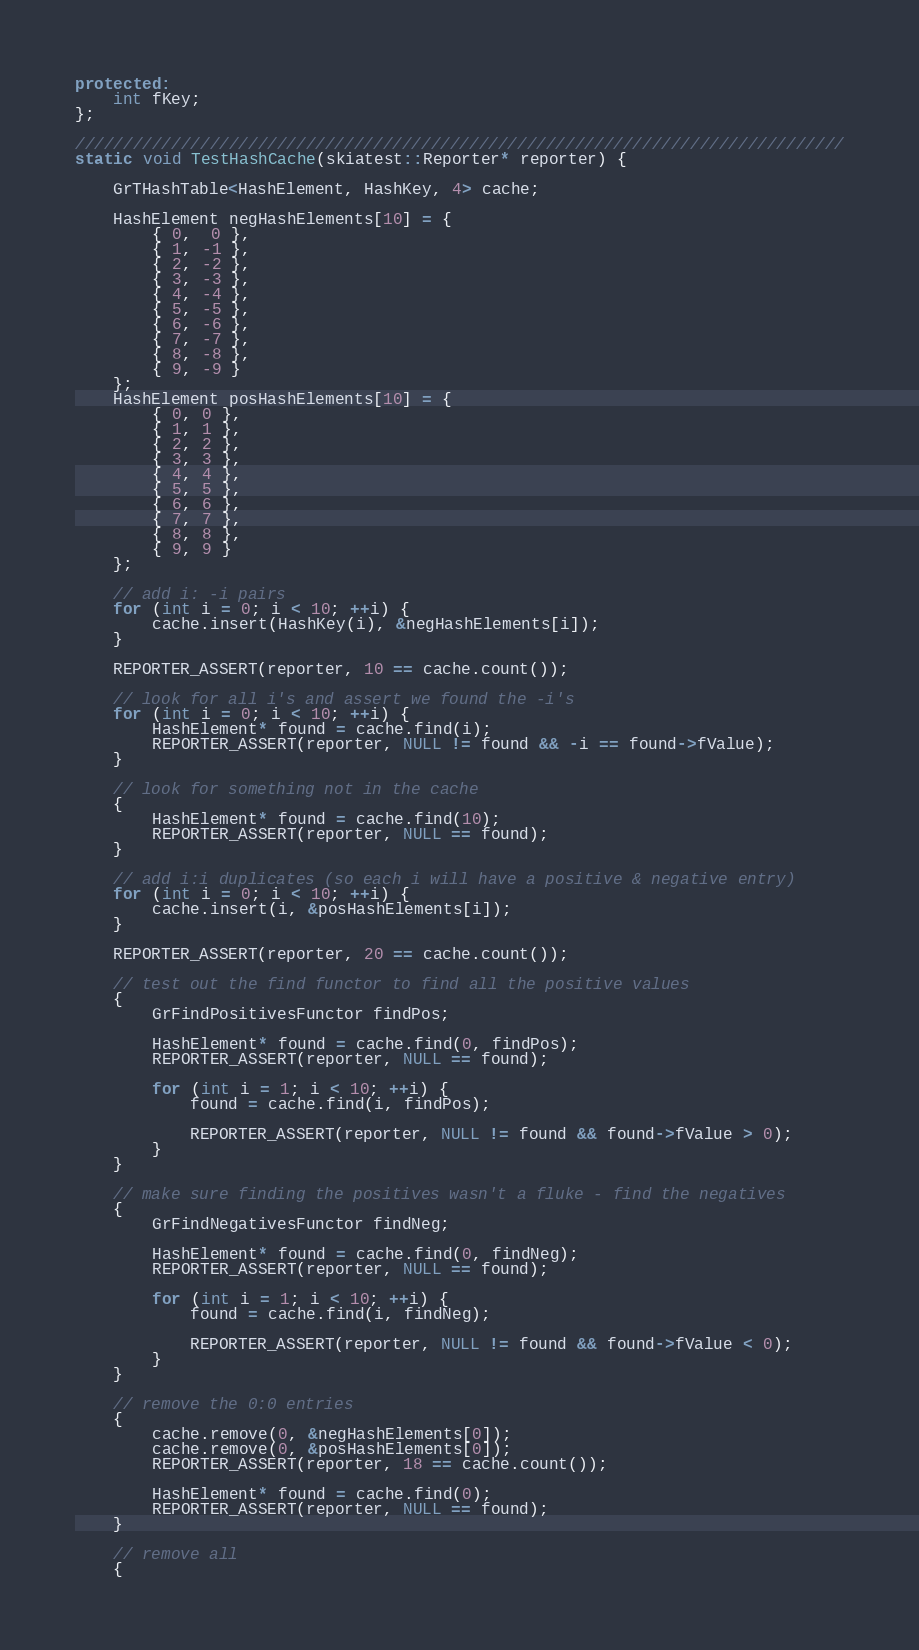Convert code to text. <code><loc_0><loc_0><loc_500><loc_500><_C++_>protected:
    int fKey;
};

////////////////////////////////////////////////////////////////////////////////
static void TestHashCache(skiatest::Reporter* reporter) {

    GrTHashTable<HashElement, HashKey, 4> cache;

    HashElement negHashElements[10] = {
        { 0,  0 },
        { 1, -1 },
        { 2, -2 },
        { 3, -3 },
        { 4, -4 },
        { 5, -5 },
        { 6, -6 },
        { 7, -7 },
        { 8, -8 },
        { 9, -9 }
    };
    HashElement posHashElements[10] = {
        { 0, 0 },
        { 1, 1 },
        { 2, 2 },
        { 3, 3 },
        { 4, 4 },
        { 5, 5 },
        { 6, 6 },
        { 7, 7 },
        { 8, 8 },
        { 9, 9 }
    };

    // add i: -i pairs
    for (int i = 0; i < 10; ++i) {
        cache.insert(HashKey(i), &negHashElements[i]);
    }

    REPORTER_ASSERT(reporter, 10 == cache.count());

    // look for all i's and assert we found the -i's
    for (int i = 0; i < 10; ++i) {
        HashElement* found = cache.find(i);
        REPORTER_ASSERT(reporter, NULL != found && -i == found->fValue);
    }

    // look for something not in the cache
    {
        HashElement* found = cache.find(10);
        REPORTER_ASSERT(reporter, NULL == found);
    }

    // add i:i duplicates (so each i will have a positive & negative entry)
    for (int i = 0; i < 10; ++i) {
        cache.insert(i, &posHashElements[i]);
    }

    REPORTER_ASSERT(reporter, 20 == cache.count());

    // test out the find functor to find all the positive values
    {
        GrFindPositivesFunctor findPos;

        HashElement* found = cache.find(0, findPos);
        REPORTER_ASSERT(reporter, NULL == found);

        for (int i = 1; i < 10; ++i) {
            found = cache.find(i, findPos);

            REPORTER_ASSERT(reporter, NULL != found && found->fValue > 0);
        }
    }

    // make sure finding the positives wasn't a fluke - find the negatives
    {
        GrFindNegativesFunctor findNeg;

        HashElement* found = cache.find(0, findNeg);
        REPORTER_ASSERT(reporter, NULL == found);

        for (int i = 1; i < 10; ++i) {
            found = cache.find(i, findNeg);

            REPORTER_ASSERT(reporter, NULL != found && found->fValue < 0);
        }
    }

    // remove the 0:0 entries
    {
        cache.remove(0, &negHashElements[0]);
        cache.remove(0, &posHashElements[0]);
        REPORTER_ASSERT(reporter, 18 == cache.count());

        HashElement* found = cache.find(0);
        REPORTER_ASSERT(reporter, NULL == found);
    }

    // remove all
    {</code> 